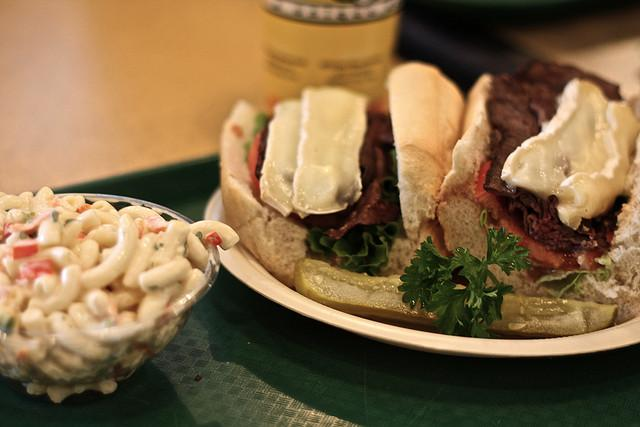What kind of pasta is on the left?

Choices:
A) bowtie
B) macaroni
C) spaghetti
D) penne macaroni 